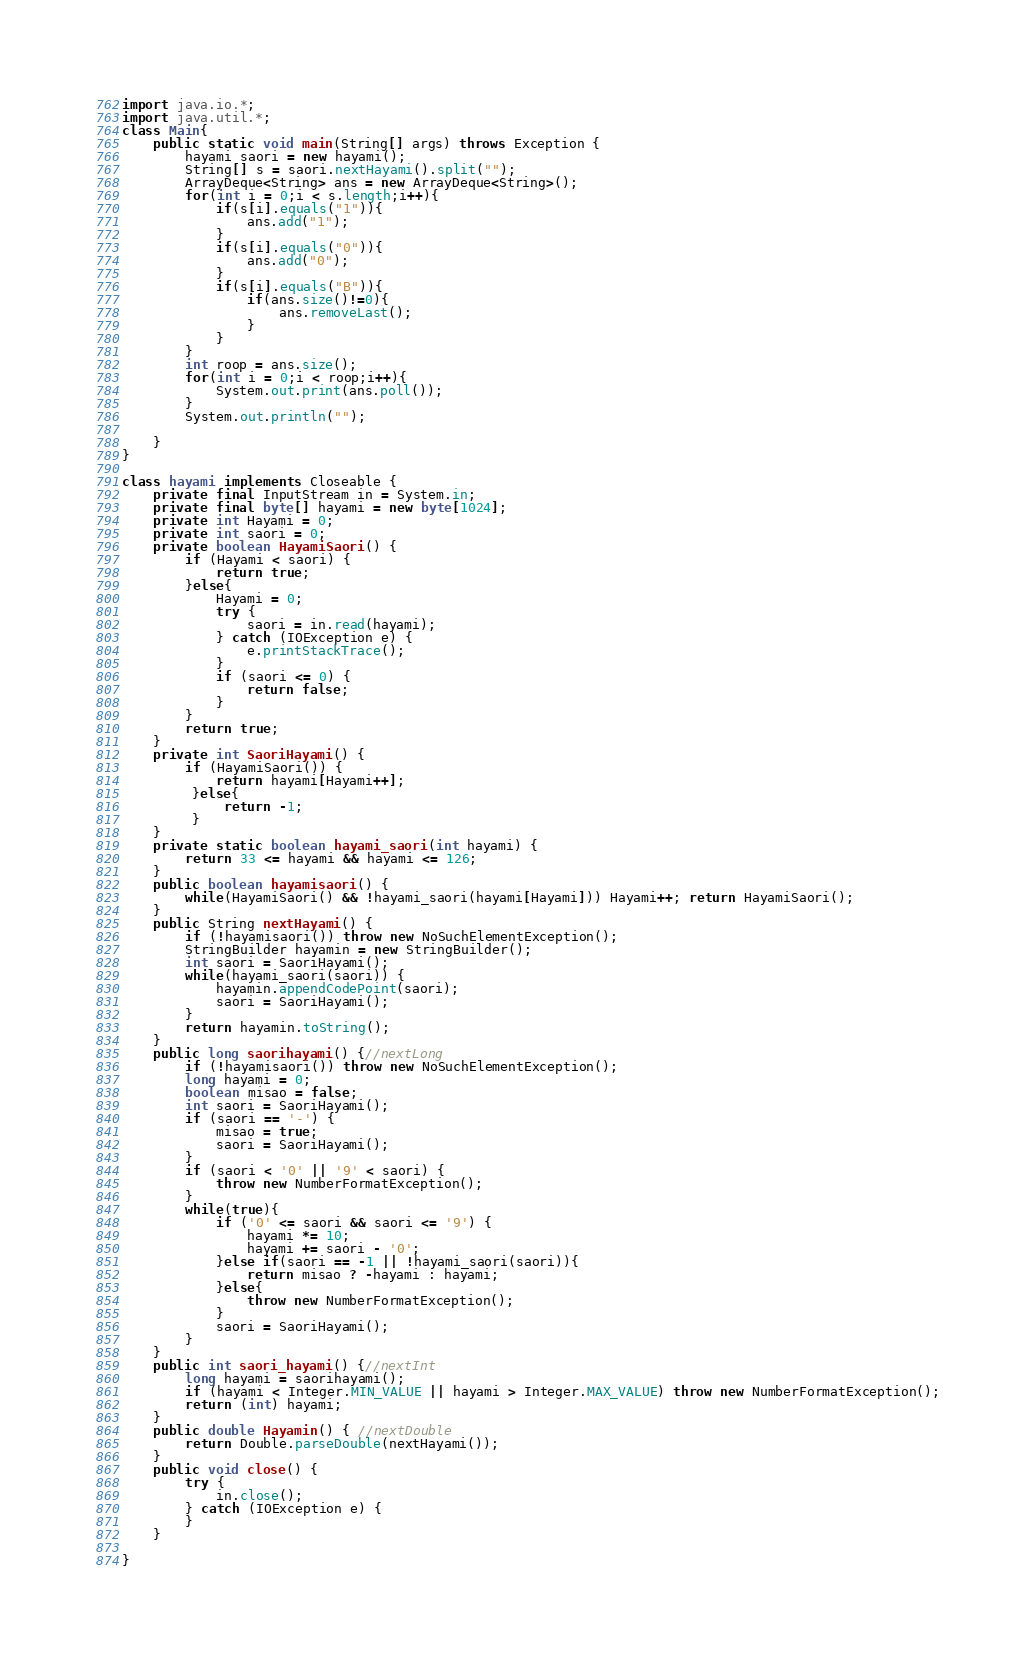Convert code to text. <code><loc_0><loc_0><loc_500><loc_500><_Java_>import java.io.*;
import java.util.*;
class Main{
    public static void main(String[] args) throws Exception {
		hayami saori = new hayami();
		String[] s = saori.nextHayami().split("");
		ArrayDeque<String> ans = new ArrayDeque<String>();
		for(int i = 0;i < s.length;i++){
			if(s[i].equals("1")){
				ans.add("1");
			}
			if(s[i].equals("0")){
				ans.add("0");
			}
			if(s[i].equals("B")){
				if(ans.size()!=0){
					ans.removeLast();
				}		
			}
		}
		int roop = ans.size();
		for(int i = 0;i < roop;i++){
			System.out.print(ans.poll());
		}
		System.out.println("");
		
    }
}

class hayami implements Closeable {
	private final InputStream in = System.in;
	private final byte[] hayami = new byte[1024];
	private int Hayami = 0;
	private int saori = 0;
	private boolean HayamiSaori() {
		if (Hayami < saori) {
			return true;
		}else{
			Hayami = 0;
			try {
				saori = in.read(hayami);
			} catch (IOException e) {
				e.printStackTrace();
			}
			if (saori <= 0) {
				return false;
			}
		}
		return true;
	}
	private int SaoriHayami() { 
		if (HayamiSaori()) {
            return hayami[Hayami++];
         }else{
             return -1;
         }
	}
	private static boolean hayami_saori(int hayami) { 
		return 33 <= hayami && hayami <= 126;
	}
	public boolean hayamisaori() { 
		while(HayamiSaori() && !hayami_saori(hayami[Hayami])) Hayami++; return HayamiSaori();
	}
	public String nextHayami() {
		if (!hayamisaori()) throw new NoSuchElementException();
		StringBuilder hayamin = new StringBuilder();
		int saori = SaoriHayami();
		while(hayami_saori(saori)) {
			hayamin.appendCodePoint(saori);
			saori = SaoriHayami();
		}
		return hayamin.toString();
	}
	public long saorihayami() {//nextLong
		if (!hayamisaori()) throw new NoSuchElementException();
		long hayami = 0;
		boolean misao = false;
		int saori = SaoriHayami();
		if (saori == '-') {
			misao = true;
			saori = SaoriHayami();
		}
		if (saori < '0' || '9' < saori) {
			throw new NumberFormatException();
		}
		while(true){
			if ('0' <= saori && saori <= '9') {
				hayami *= 10;
				hayami += saori - '0';
			}else if(saori == -1 || !hayami_saori(saori)){
				return misao ? -hayami : hayami;
			}else{
				throw new NumberFormatException();
			}
			saori = SaoriHayami();
		}
	}
	public int saori_hayami() {//nextInt
		long hayami = saorihayami();
		if (hayami < Integer.MIN_VALUE || hayami > Integer.MAX_VALUE) throw new NumberFormatException();
		return (int) hayami;
	}
	public double Hayamin() { //nextDouble
		return Double.parseDouble(nextHayami());
	}
	public void close() {
		try {
			in.close();
		} catch (IOException e) {
		}
    }
    
}</code> 